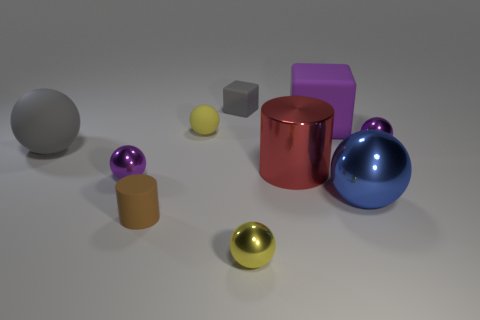Subtract 2 spheres. How many spheres are left? 4 Subtract all yellow spheres. How many spheres are left? 4 Subtract all purple balls. How many balls are left? 4 Subtract all purple spheres. Subtract all yellow cylinders. How many spheres are left? 4 Subtract all spheres. How many objects are left? 4 Subtract 0 blue cubes. How many objects are left? 10 Subtract all big red metallic things. Subtract all small purple cubes. How many objects are left? 9 Add 1 blue balls. How many blue balls are left? 2 Add 4 large cyan cylinders. How many large cyan cylinders exist? 4 